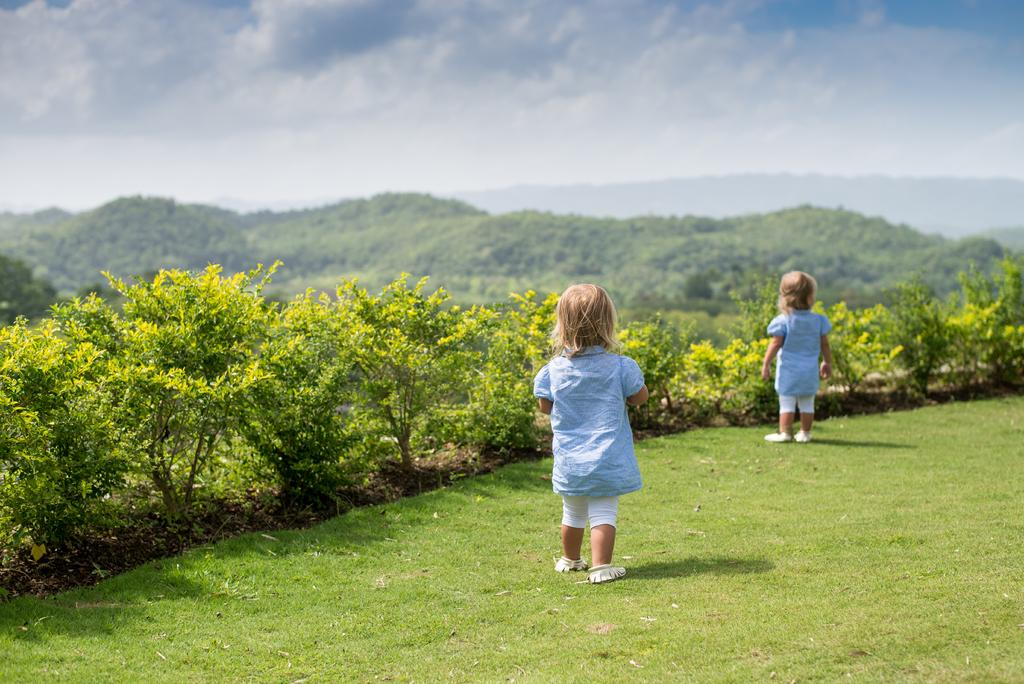How many kids are in the image? There are two kids on the ground in the image. What else can be seen in the image besides the kids? Plants are visible in the image. What is visible in the background of the image? There are mountains and the sky in the background of the image. What can be observed in the sky? Clouds are present in the sky. What type of pain is the kid experiencing in the image? There is no indication in the image that the kids are experiencing any pain. 